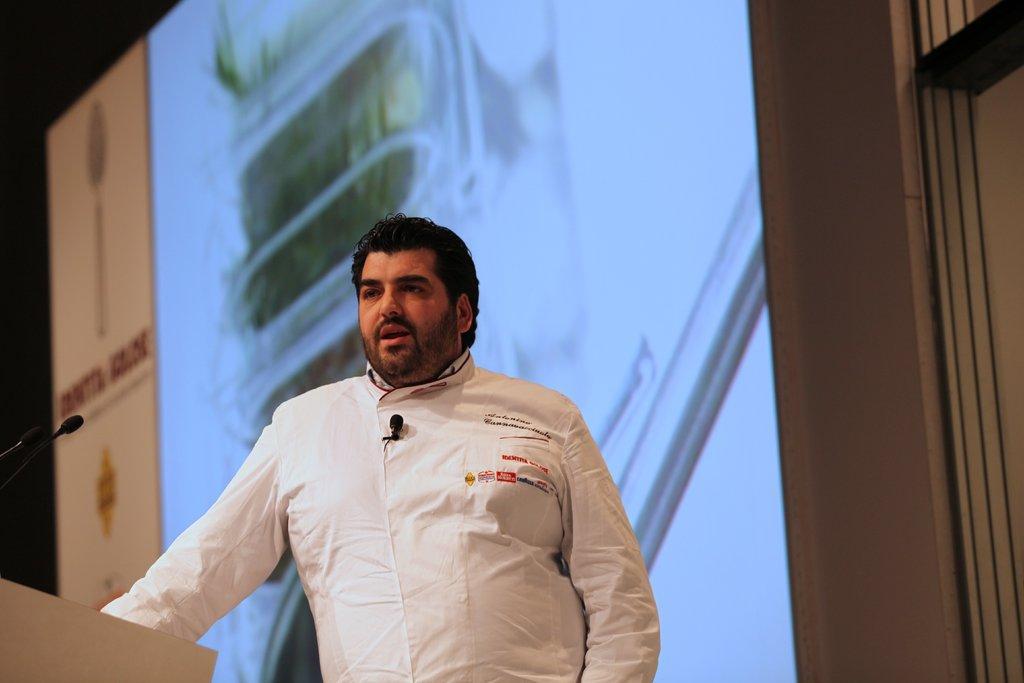In one or two sentences, can you explain what this image depicts? In this picture we can see a man standing at the podium, mics and in the background we can see a screen. 